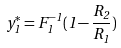<formula> <loc_0><loc_0><loc_500><loc_500>y _ { 1 } ^ { * } = F _ { 1 } ^ { - 1 } ( 1 - \frac { R _ { 2 } } { R _ { 1 } } )</formula> 